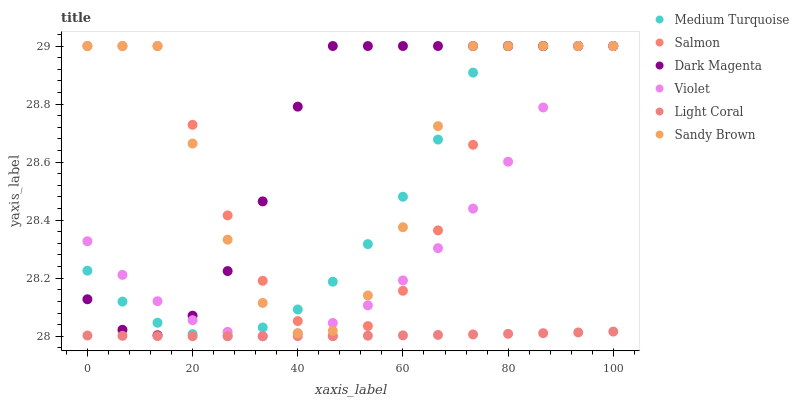Does Light Coral have the minimum area under the curve?
Answer yes or no. Yes. Does Dark Magenta have the maximum area under the curve?
Answer yes or no. Yes. Does Salmon have the minimum area under the curve?
Answer yes or no. No. Does Salmon have the maximum area under the curve?
Answer yes or no. No. Is Light Coral the smoothest?
Answer yes or no. Yes. Is Sandy Brown the roughest?
Answer yes or no. Yes. Is Salmon the smoothest?
Answer yes or no. No. Is Salmon the roughest?
Answer yes or no. No. Does Light Coral have the lowest value?
Answer yes or no. Yes. Does Salmon have the lowest value?
Answer yes or no. No. Does Sandy Brown have the highest value?
Answer yes or no. Yes. Does Light Coral have the highest value?
Answer yes or no. No. Is Light Coral less than Violet?
Answer yes or no. Yes. Is Dark Magenta greater than Light Coral?
Answer yes or no. Yes. Does Violet intersect Dark Magenta?
Answer yes or no. Yes. Is Violet less than Dark Magenta?
Answer yes or no. No. Is Violet greater than Dark Magenta?
Answer yes or no. No. Does Light Coral intersect Violet?
Answer yes or no. No. 